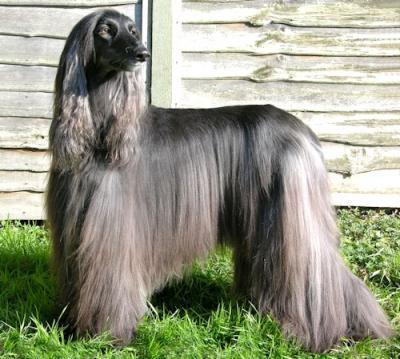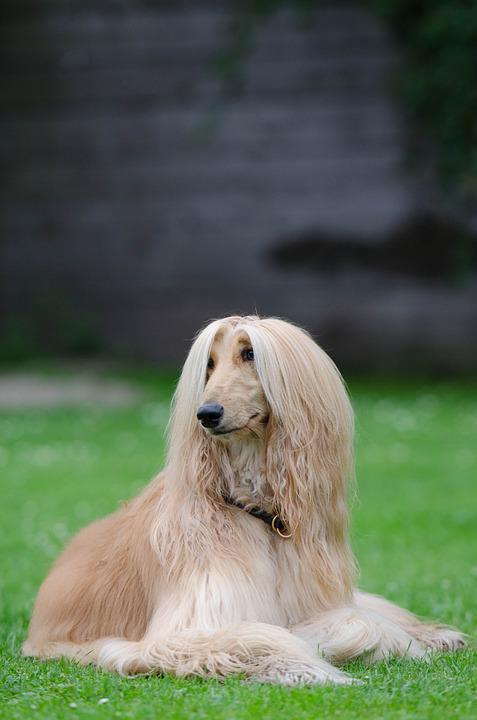The first image is the image on the left, the second image is the image on the right. For the images shown, is this caption "One image has a dog facing left but looking to the right." true? Answer yes or no. Yes. 